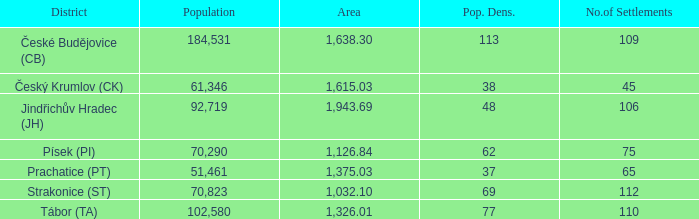Give me the full table as a dictionary. {'header': ['District', 'Population', 'Area', 'Pop. Dens.', 'No.of Settlements'], 'rows': [['České Budějovice (CB)', '184,531', '1,638.30', '113', '109'], ['Český Krumlov (CK)', '61,346', '1,615.03', '38', '45'], ['Jindřichův Hradec (JH)', '92,719', '1,943.69', '48', '106'], ['Písek (PI)', '70,290', '1,126.84', '62', '75'], ['Prachatice (PT)', '51,461', '1,375.03', '37', '65'], ['Strakonice (ST)', '70,823', '1,032.10', '69', '112'], ['Tábor (TA)', '102,580', '1,326.01', '77', '110']]} 84? 70290.0. 